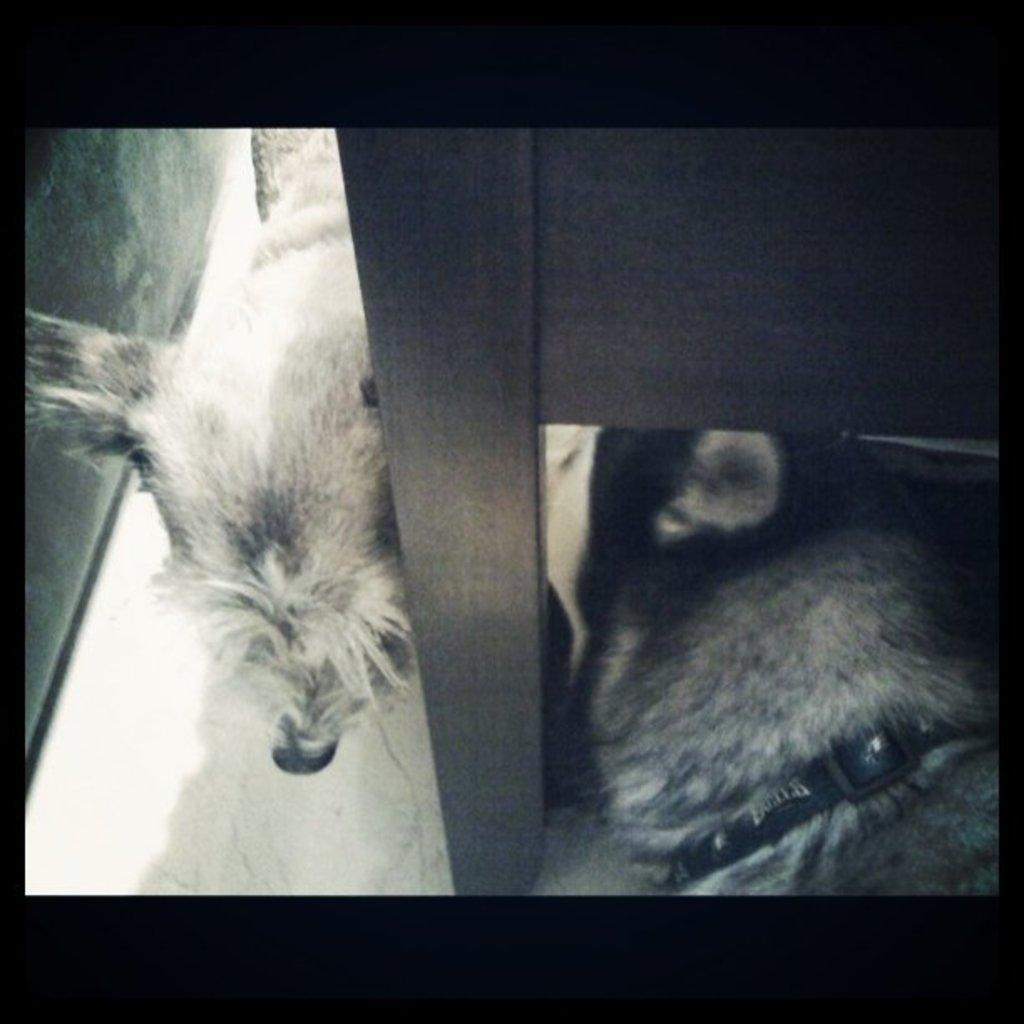What is the main subject of the image? The main subject of the image is a group of animals. Can you describe the position of one of the animals in the image? One animal is laying under a bench in the image. What type of shoes are the animals wearing in the image? There are no shoes present in the image, as the animals are not wearing any. 